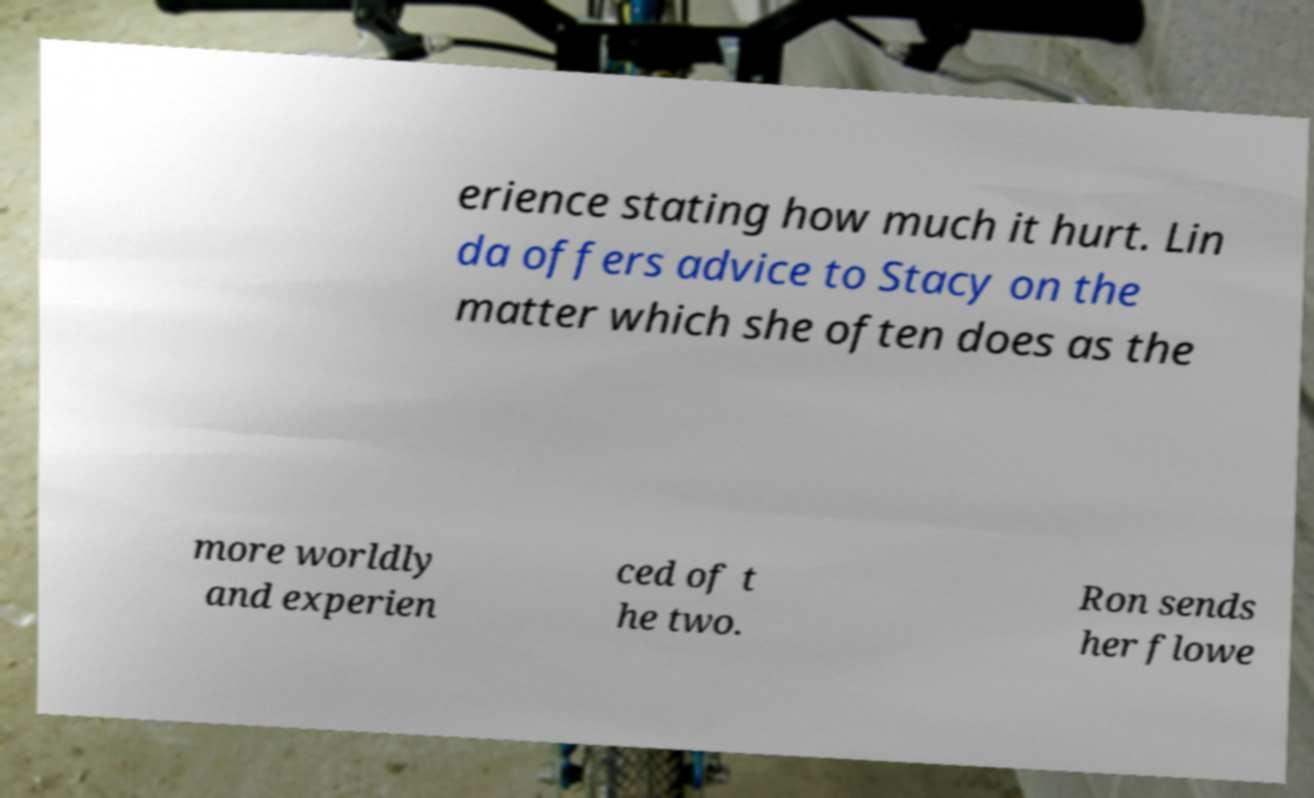I need the written content from this picture converted into text. Can you do that? erience stating how much it hurt. Lin da offers advice to Stacy on the matter which she often does as the more worldly and experien ced of t he two. Ron sends her flowe 